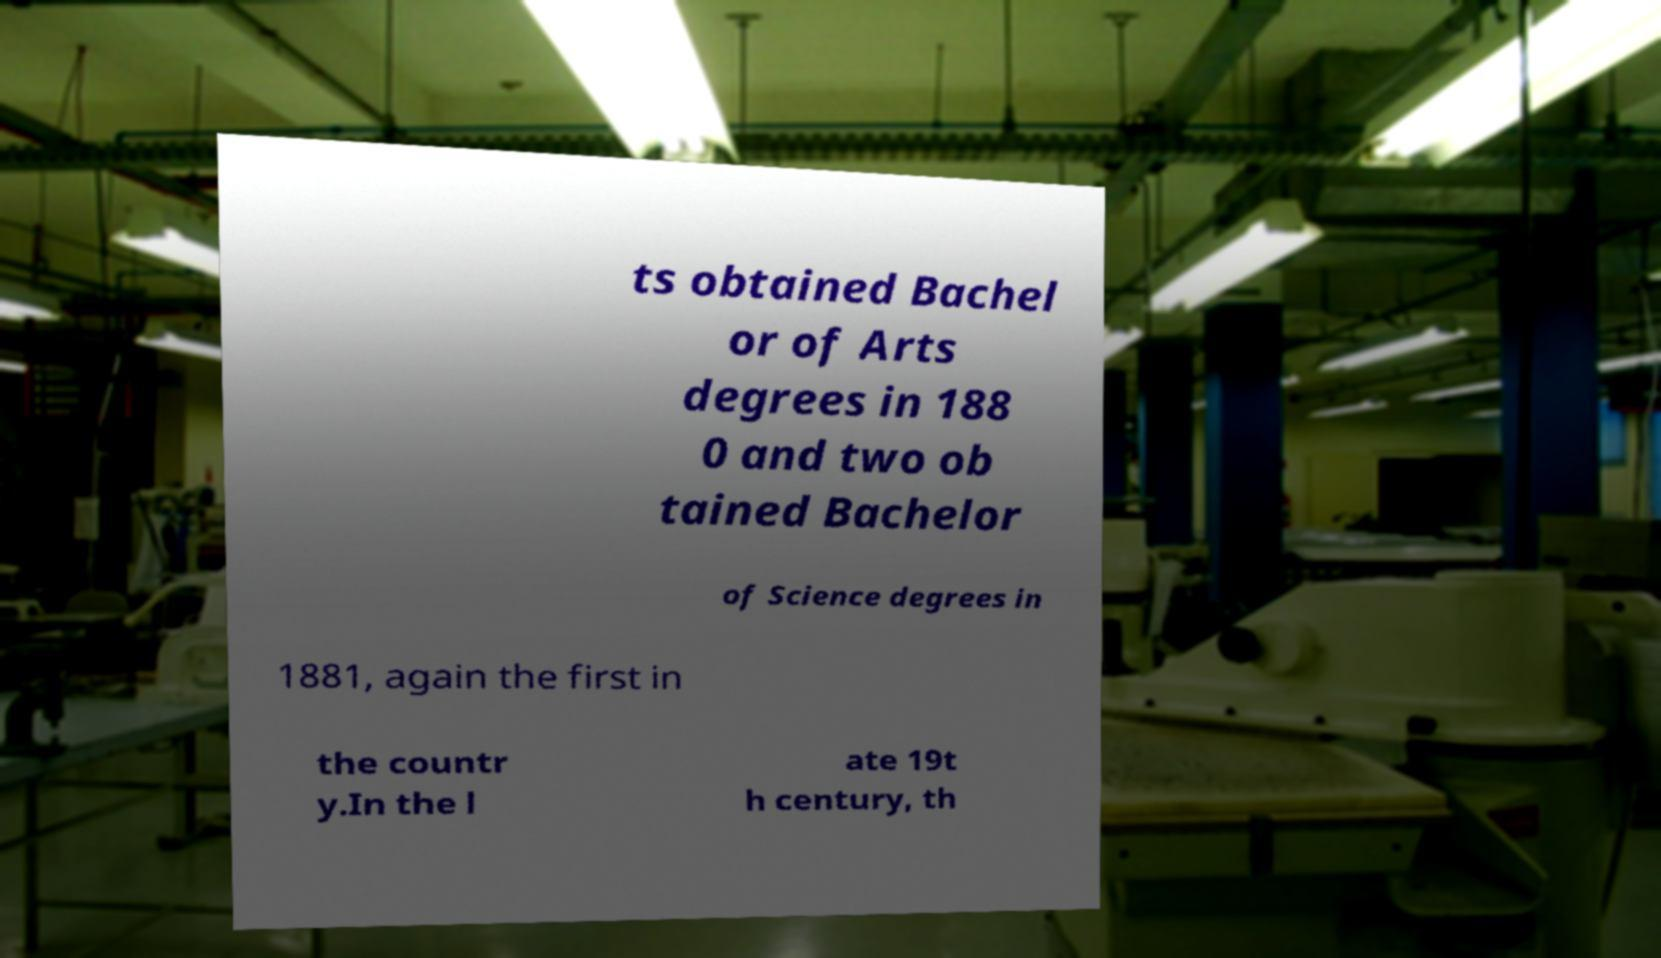Please read and relay the text visible in this image. What does it say? ts obtained Bachel or of Arts degrees in 188 0 and two ob tained Bachelor of Science degrees in 1881, again the first in the countr y.In the l ate 19t h century, th 